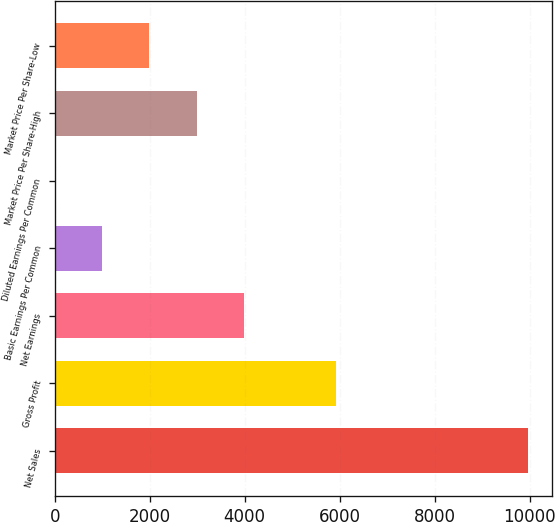<chart> <loc_0><loc_0><loc_500><loc_500><bar_chart><fcel>Net Sales<fcel>Gross Profit<fcel>Net Earnings<fcel>Basic Earnings Per Common<fcel>Diluted Earnings Per Common<fcel>Market Price Per Share-High<fcel>Market Price Per Share-Low<nl><fcel>9967.8<fcel>5922.8<fcel>3987.68<fcel>997.61<fcel>0.92<fcel>2990.99<fcel>1994.3<nl></chart> 